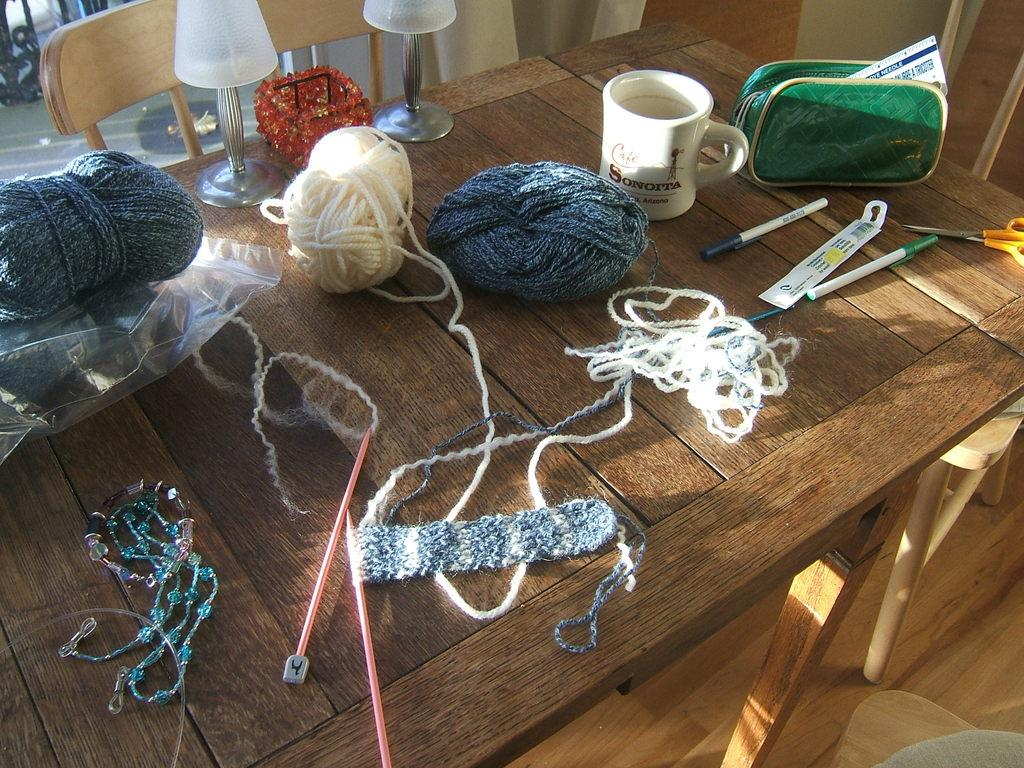What type of material is present in the image? There is wool and thread in the image. What objects can be seen in the image that are used for creating or crafting? There are sticks, a chain, a lamp, a cup, a bag, a pen, and scissors in the image. What piece of furniture is visible in the background of the image? There is a chair in the background of the image. What advice is being given in the image? There is no indication of any advice being given in the image. Can you see the thumb of the person in the image? There is no person present in the image, so it is not possible to see their thumb. 